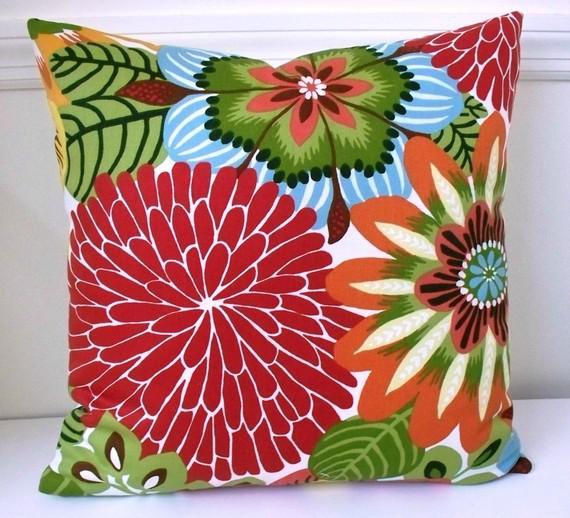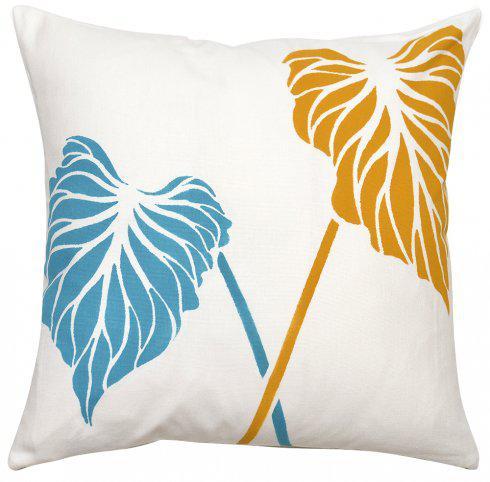The first image is the image on the left, the second image is the image on the right. Considering the images on both sides, is "There are at least 2 pillows in the right image." valid? Answer yes or no. No. The first image is the image on the left, the second image is the image on the right. Assess this claim about the two images: "One of the images has at least part of its pillow decoration written mostly in black ink.". Correct or not? Answer yes or no. No. 